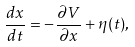<formula> <loc_0><loc_0><loc_500><loc_500>\frac { d x } { d t } = - \frac { \partial V } { \partial x } + \eta ( t ) ,</formula> 